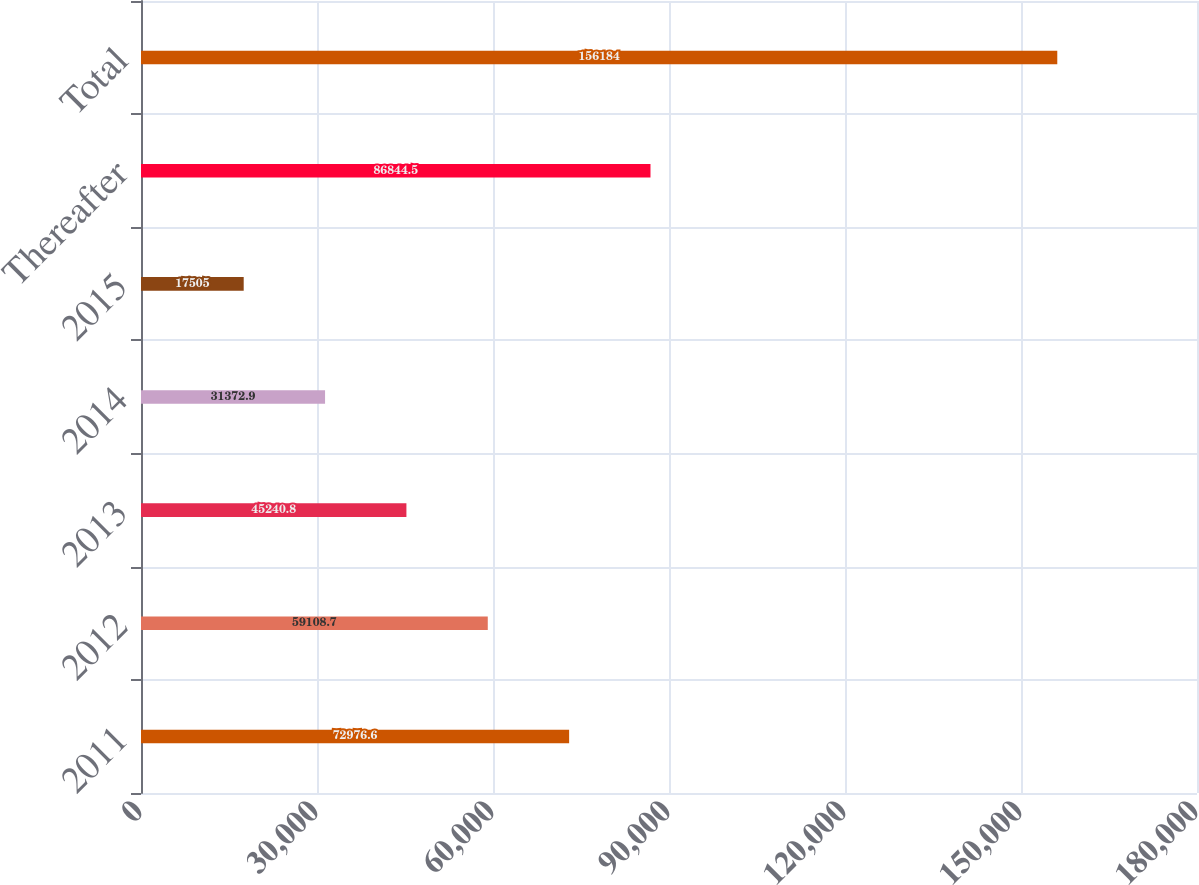Convert chart to OTSL. <chart><loc_0><loc_0><loc_500><loc_500><bar_chart><fcel>2011<fcel>2012<fcel>2013<fcel>2014<fcel>2015<fcel>Thereafter<fcel>Total<nl><fcel>72976.6<fcel>59108.7<fcel>45240.8<fcel>31372.9<fcel>17505<fcel>86844.5<fcel>156184<nl></chart> 